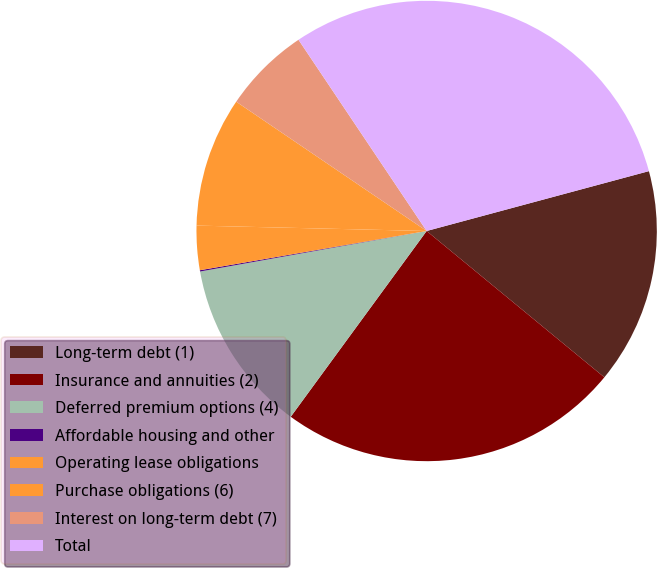Convert chart. <chart><loc_0><loc_0><loc_500><loc_500><pie_chart><fcel>Long-term debt (1)<fcel>Insurance and annuities (2)<fcel>Deferred premium options (4)<fcel>Affordable housing and other<fcel>Operating lease obligations<fcel>Purchase obligations (6)<fcel>Interest on long-term debt (7)<fcel>Total<nl><fcel>15.15%<fcel>24.09%<fcel>12.13%<fcel>0.09%<fcel>3.1%<fcel>9.12%<fcel>6.11%<fcel>30.21%<nl></chart> 